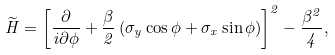Convert formula to latex. <formula><loc_0><loc_0><loc_500><loc_500>\widetilde { H } = \left [ \frac { \partial } { i \partial { \phi } } + \frac { \beta } { 2 } \left ( \sigma _ { y } \cos \phi + \sigma _ { x } \sin \phi \right ) \right ] ^ { 2 } - \frac { \beta ^ { 2 } } { 4 } ,</formula> 